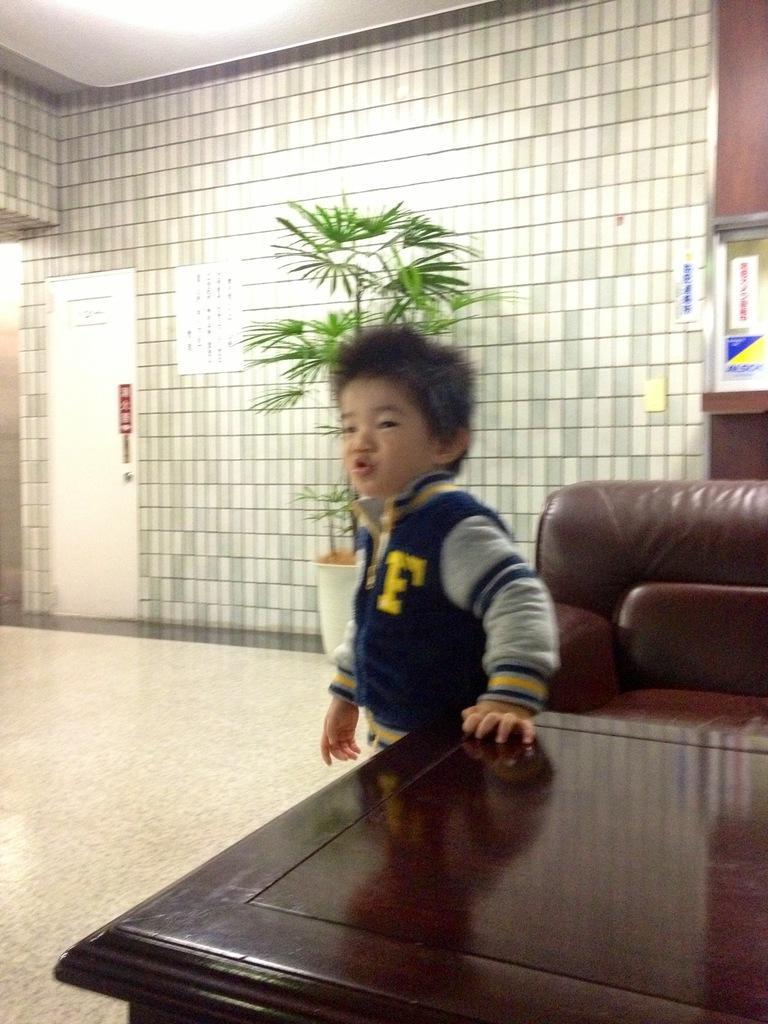How would you summarize this image in a sentence or two? A boy with the blue jacket is standing. He kept his hand on the table. Behind the table there is a sofa. In the background there is a plant and a wall. And to the left side there is a door. 